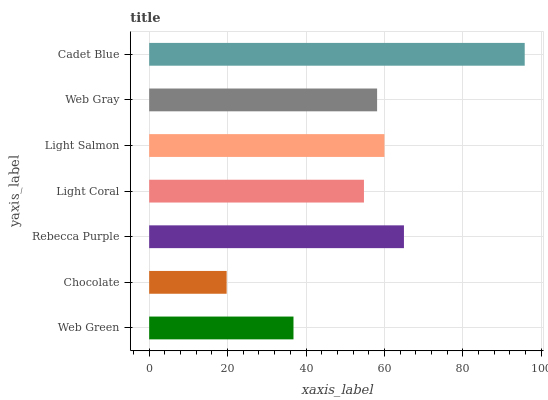Is Chocolate the minimum?
Answer yes or no. Yes. Is Cadet Blue the maximum?
Answer yes or no. Yes. Is Rebecca Purple the minimum?
Answer yes or no. No. Is Rebecca Purple the maximum?
Answer yes or no. No. Is Rebecca Purple greater than Chocolate?
Answer yes or no. Yes. Is Chocolate less than Rebecca Purple?
Answer yes or no. Yes. Is Chocolate greater than Rebecca Purple?
Answer yes or no. No. Is Rebecca Purple less than Chocolate?
Answer yes or no. No. Is Web Gray the high median?
Answer yes or no. Yes. Is Web Gray the low median?
Answer yes or no. Yes. Is Rebecca Purple the high median?
Answer yes or no. No. Is Light Salmon the low median?
Answer yes or no. No. 